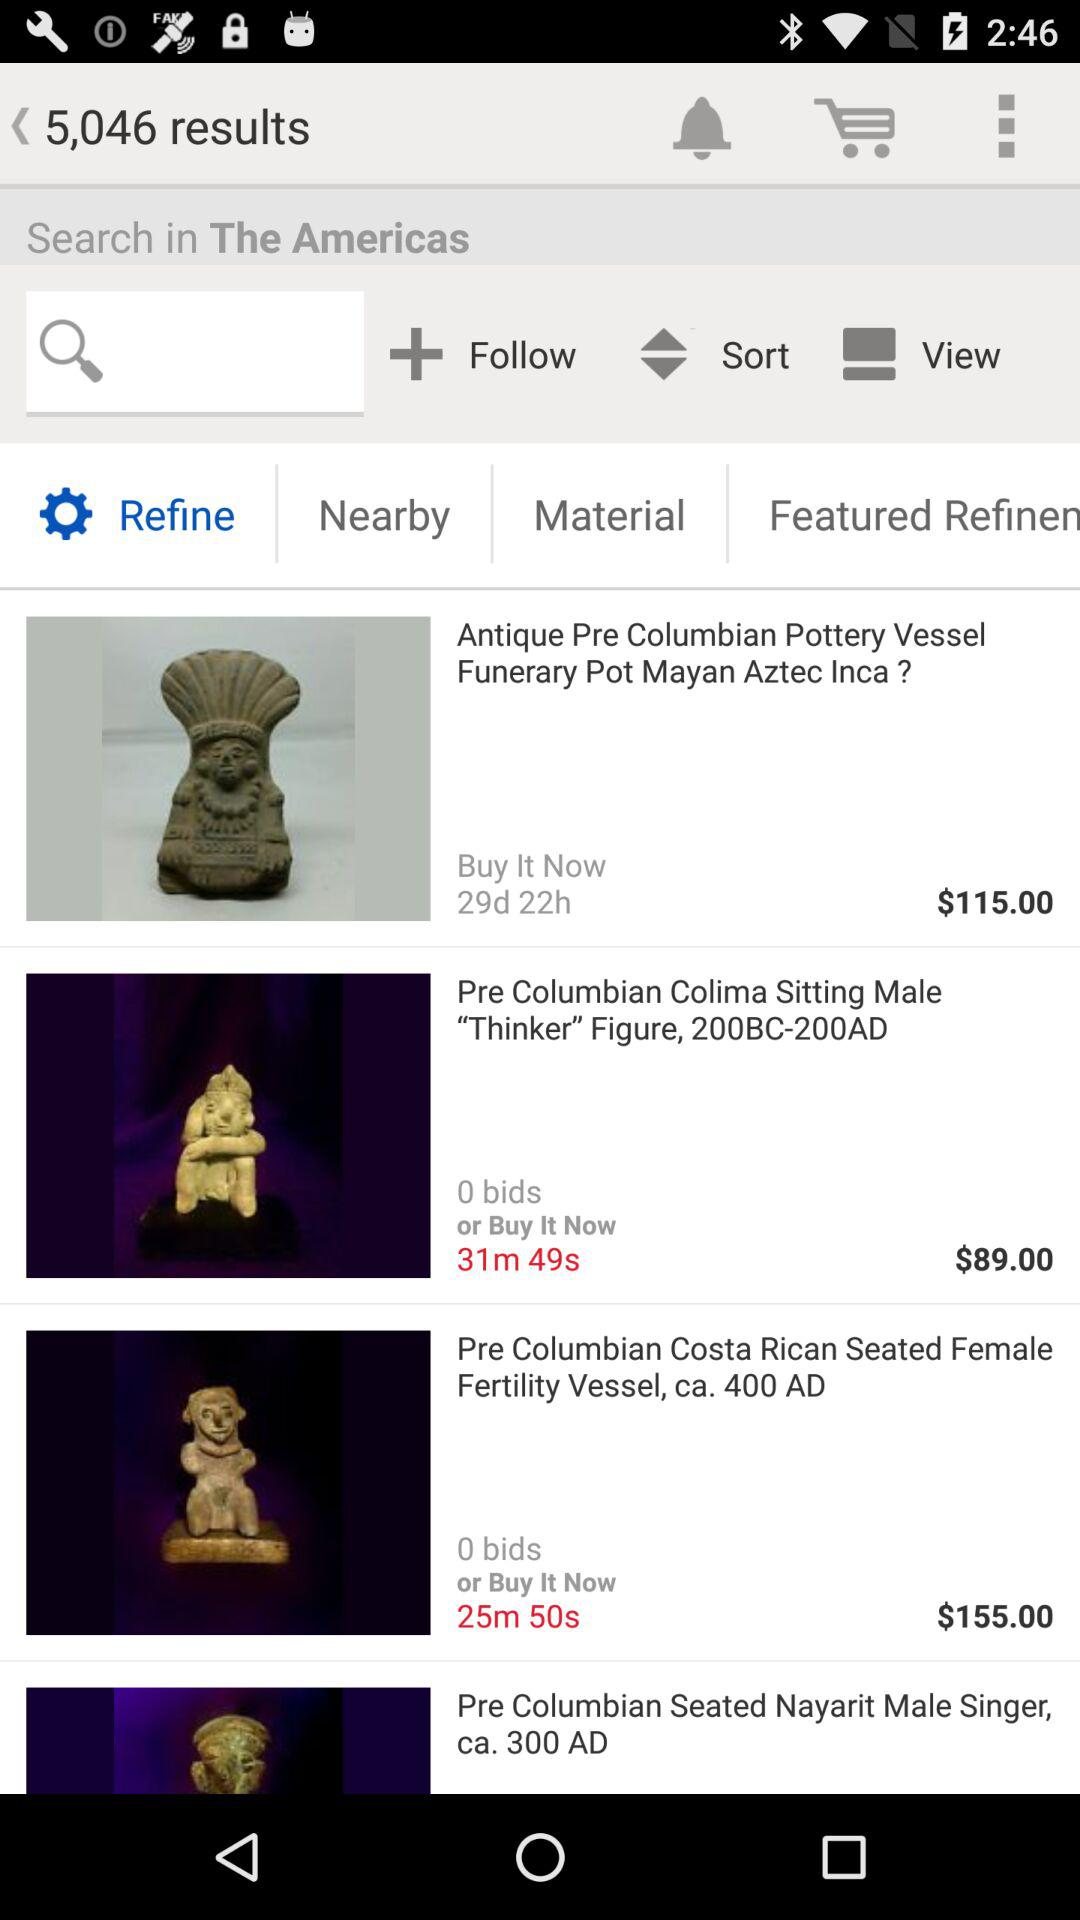Which tab is selected? The selected tab is "Refine". 